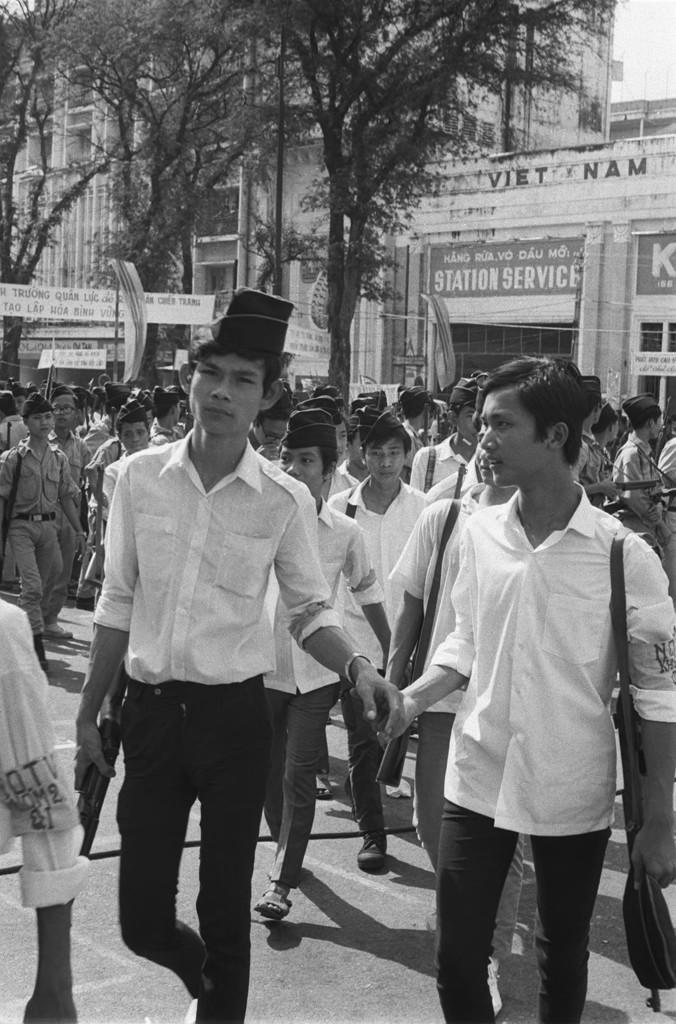Describe this image in one or two sentences. In this picture we can see a group of people on the road and in the background we can see banners, posters, buildings, trees and some objects. 